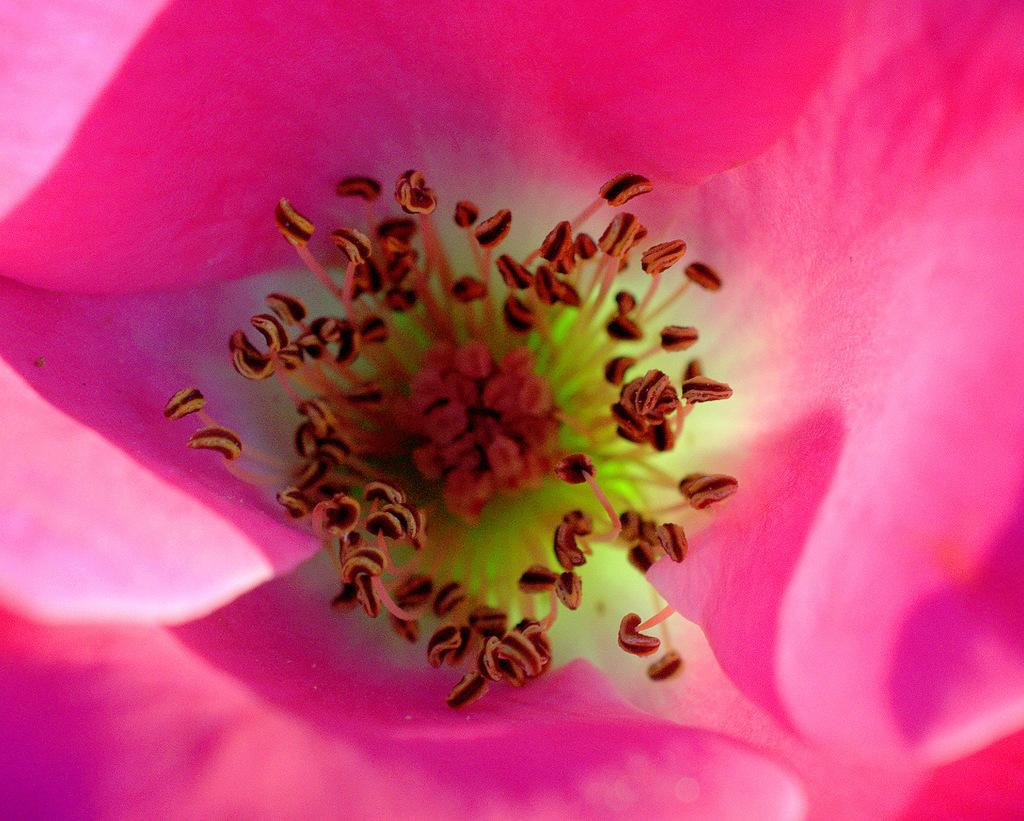What is the main subject of the image? The main subject of the image is a flower. What can be found in the center of the flower? The flower has pollen grains in the center. What color are the petals of the flower? The flower has pink petals. What type of hat is the flower wearing in the image? There is no hat present in the image; it is a flower with pink petals and pollen grains in the center. 